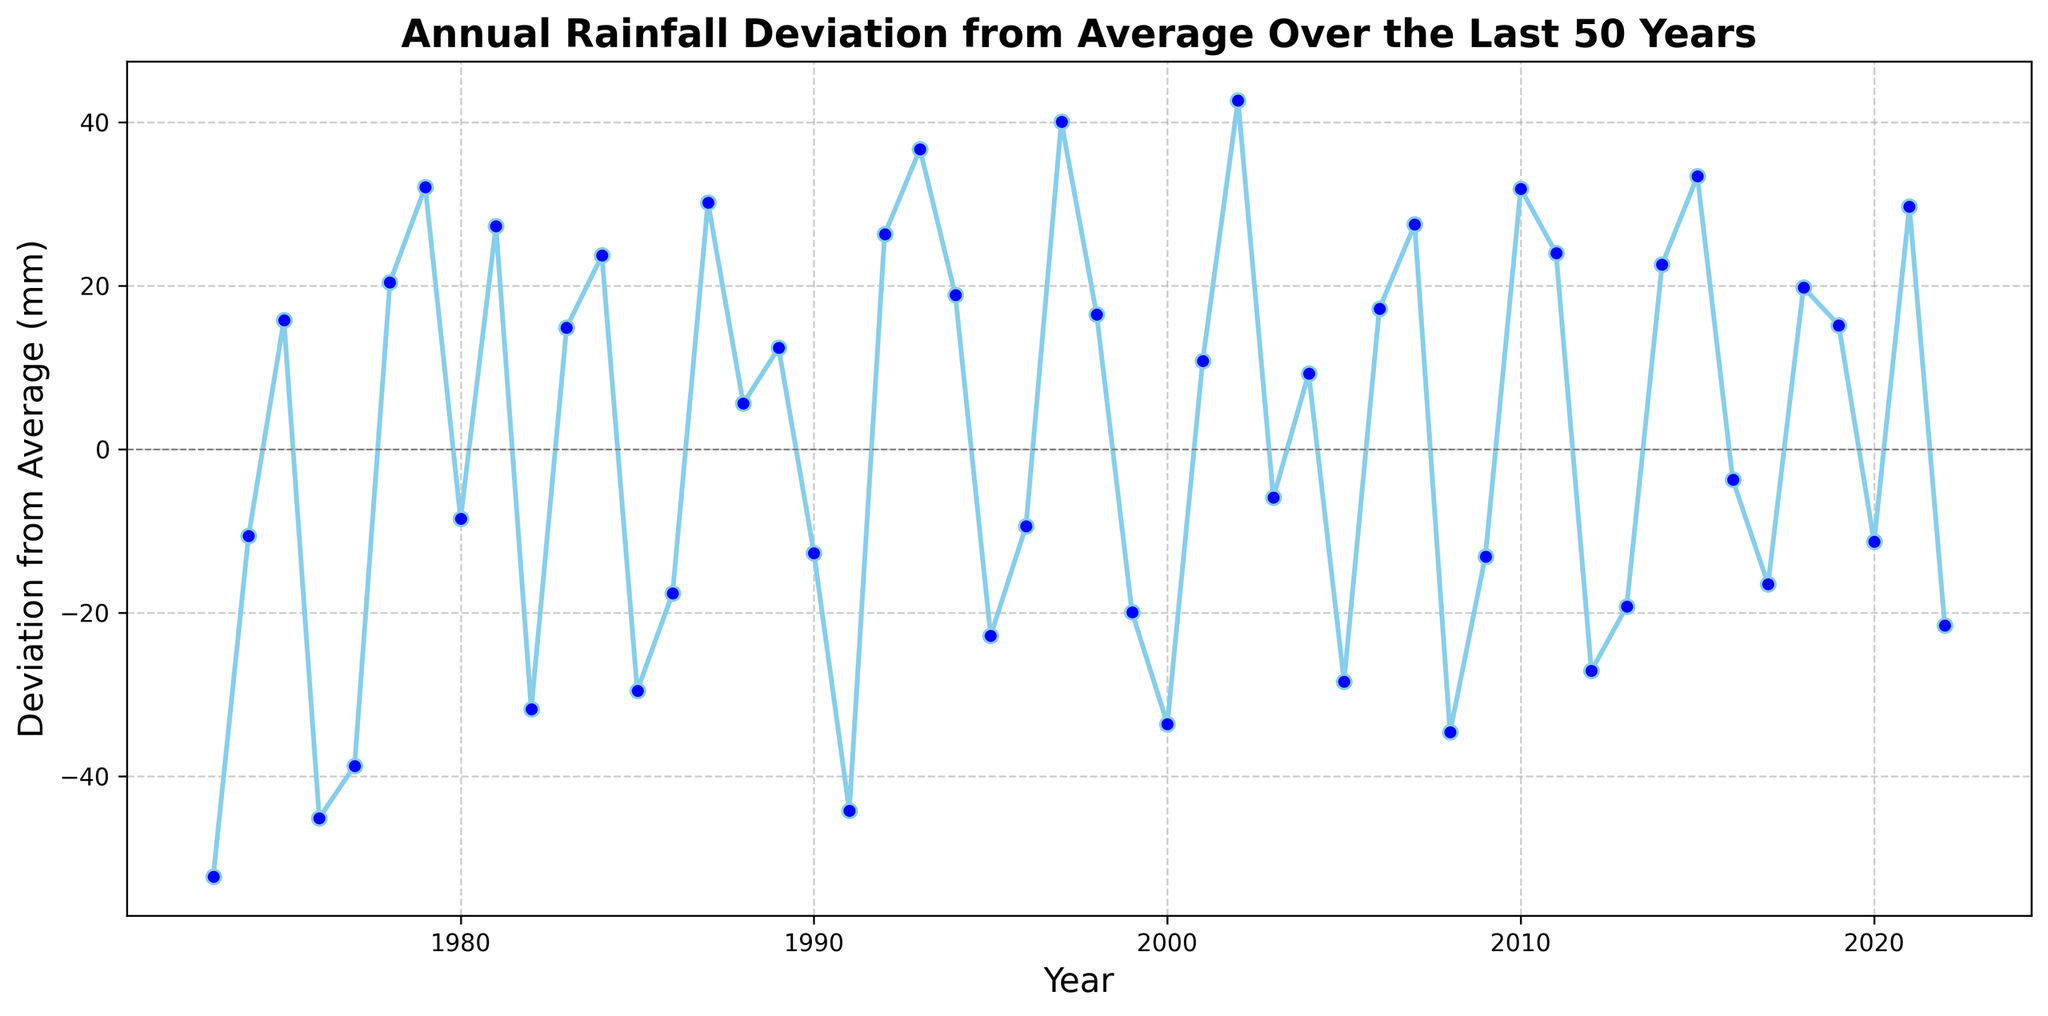When was the largest negative deviation recorded, and what was its value? The largest negative deviation is identified by locating the lowest point on the line chart. This occurs in 1973 with a value of -52.3 mm.
Answer: 1973, -52.3 mm Which year showed the highest positive deviation, and by how much? The highest positive deviation can be found by looking for the peak on the line chart. This occurs in 2002 with a value of 42.7 mm.
Answer: 2002, 42.7 mm Compare the deviation in 1987 with that of 1997. Which year had a higher positive deviation and by how much? From the chart, 1987 had a deviation of 30.2 mm and 1997 had a deviation of 40.1 mm. 1997 had a higher positive deviation by 40.1 - 30.2 = 9.9 mm.
Answer: 1997, 9.9 mm How many years had a negative deviation from average? Count the points below the 0 line on the y-axis. There are 24 such years.
Answer: 24 years Across the 50 years, what is the average deviation from the average rainfall? Sum up all deviations and divide by the number of years. Sum = -52.3 + (-10.6) + 15.8 + (-45.1) + (-38.7) + 20.4 + 32.1 + (-8.5) + 27.3 + (-31.8) + 14.9 + 23.7 + (-29.5) + (-17.6) + 30.2 + 5.6 + 12.4 + (-12.7) + (-44.2) + 26.3 + 36.7 + 18.9 + (-22.8) + (-9.4) + 40.1 + 16.5 + (-19.9) + (-33.6) + 10.8 + 42.7 + (-5.9) + 9.3 + (-28.4) + 17.2 + 27.5 + (-34.6) + (-13.1) + 31.9 + 24.0 + (-27.1) + (-19.2) + 22.6 + 33.4 + (-3.7) + (-16.5) + 19.8 + 15.2 + (-11.3) + 29.7 + (-21.5) = 163.2. The average deviation is 163.2 / 50 = 3.26 mm.
Answer: 3.26 mm Find the total deviation for the decade from 1990 to 1999. Add the deviations for each year from 1990 to 1999: -12.7 + (-44.2) + 26.3 + 36.7 + 18.9 + (-22.8) + (-9.4) + 40.1 + 16.5 + (-19.9) = 29.5 mm.
Answer: 29.5 mm Which year had a deviation closest to zero, and what was its value? Find the data point closest to the zero line. The closest value is in 2003 with a deviation of -5.9 mm.
Answer: 2003, -5.9 mm How does the deviation in 2010 compare to the deviation in 2020? In 2010, the deviation was 31.9 mm, while in 2020, it was -11.3 mm. The deviation in 2010 was greater by 31.9 - (-11.3) = 43.2 mm.
Answer: 2010, 43.2 mm Identify the years with the three highest positive deviations. The highest positive deviations occurred in 2002 (42.7 mm), 1997 (40.1 mm), and 1979 (32.1 mm).
Answer: 2002, 1997, 1979 What was the average deviation for the decade from 2010 to 2019? Add the deviations for each year from 2010 to 2019 and divide by 10: 31.9 + 24.0 + (-27.1) + (-19.2) + 22.6 + 33.4 + (-3.7) + (-16.5) + 19.8 + 15.2 = 80.4. The average deviation is 80.4 / 10 = 8.04 mm.
Answer: 8.04 mm 